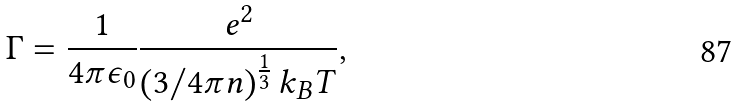Convert formula to latex. <formula><loc_0><loc_0><loc_500><loc_500>\Gamma = \frac { 1 } { 4 \pi \epsilon _ { 0 } } \frac { e ^ { 2 } } { \left ( 3 / 4 \pi n \right ) ^ { \frac { 1 } { 3 } } k _ { B } T } ,</formula> 